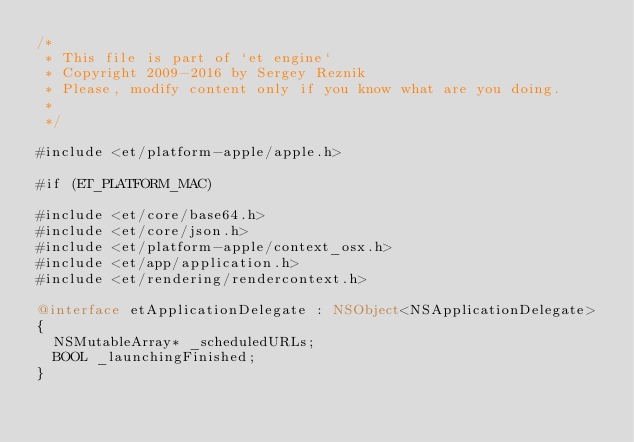<code> <loc_0><loc_0><loc_500><loc_500><_ObjectiveC_>/*
 * This file is part of `et engine`
 * Copyright 2009-2016 by Sergey Reznik
 * Please, modify content only if you know what are you doing.
 *
 */

#include <et/platform-apple/apple.h>

#if (ET_PLATFORM_MAC)

#include <et/core/base64.h>
#include <et/core/json.h>
#include <et/platform-apple/context_osx.h>
#include <et/app/application.h>
#include <et/rendering/rendercontext.h>

@interface etApplicationDelegate : NSObject<NSApplicationDelegate>
{
	NSMutableArray* _scheduledURLs;
	BOOL _launchingFinished;
}
</code> 